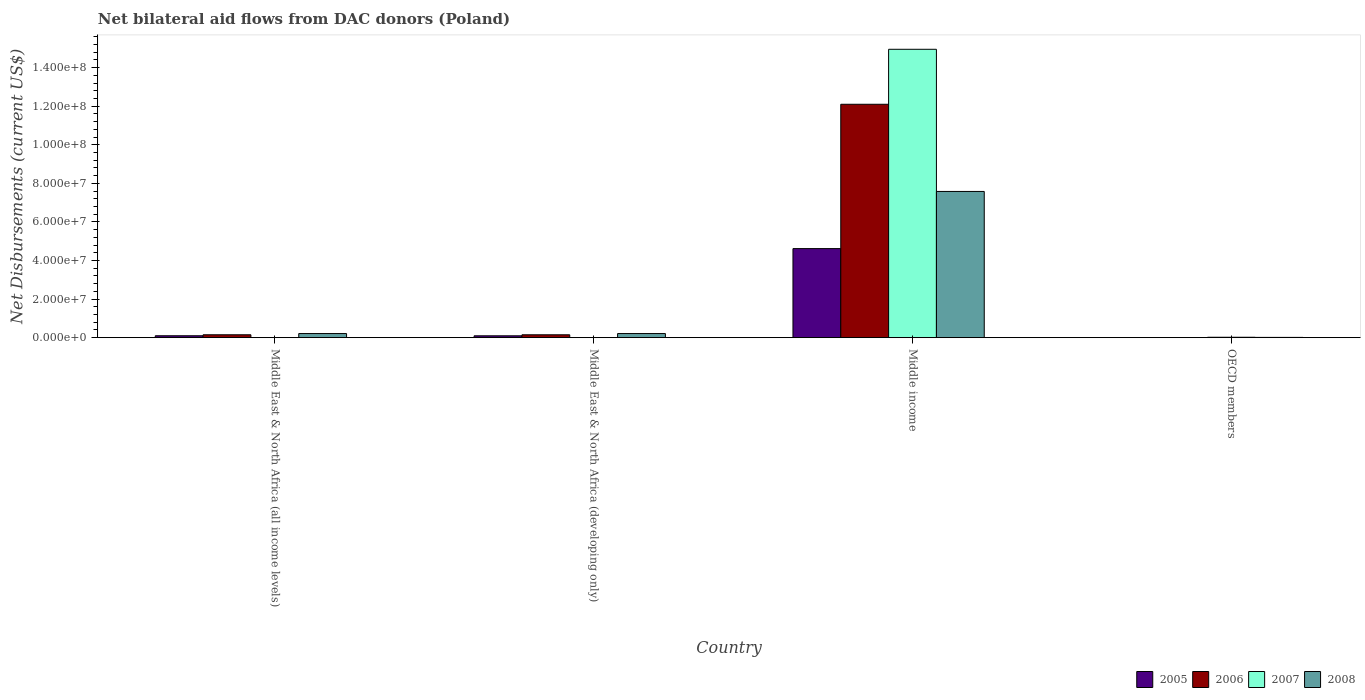Are the number of bars per tick equal to the number of legend labels?
Your response must be concise. No. Are the number of bars on each tick of the X-axis equal?
Keep it short and to the point. No. How many bars are there on the 1st tick from the left?
Keep it short and to the point. 3. How many bars are there on the 4th tick from the right?
Your answer should be compact. 3. What is the label of the 4th group of bars from the left?
Offer a very short reply. OECD members. What is the net bilateral aid flows in 2006 in Middle East & North Africa (developing only)?
Offer a very short reply. 1.49e+06. Across all countries, what is the maximum net bilateral aid flows in 2008?
Provide a short and direct response. 7.58e+07. Across all countries, what is the minimum net bilateral aid flows in 2006?
Your response must be concise. 3.00e+04. What is the total net bilateral aid flows in 2008 in the graph?
Keep it short and to the point. 8.02e+07. What is the difference between the net bilateral aid flows in 2006 in Middle East & North Africa (all income levels) and that in Middle income?
Keep it short and to the point. -1.20e+08. What is the difference between the net bilateral aid flows in 2008 in Middle East & North Africa (developing only) and the net bilateral aid flows in 2006 in OECD members?
Your answer should be very brief. 2.10e+06. What is the average net bilateral aid flows in 2006 per country?
Offer a terse response. 3.10e+07. In how many countries, is the net bilateral aid flows in 2008 greater than 56000000 US$?
Provide a short and direct response. 1. What is the ratio of the net bilateral aid flows in 2008 in Middle East & North Africa (all income levels) to that in Middle East & North Africa (developing only)?
Keep it short and to the point. 1. Is the net bilateral aid flows in 2008 in Middle East & North Africa (all income levels) less than that in Middle East & North Africa (developing only)?
Ensure brevity in your answer.  No. Is the difference between the net bilateral aid flows in 2005 in Middle East & North Africa (developing only) and OECD members greater than the difference between the net bilateral aid flows in 2008 in Middle East & North Africa (developing only) and OECD members?
Your response must be concise. No. What is the difference between the highest and the second highest net bilateral aid flows in 2005?
Offer a terse response. 4.52e+07. What is the difference between the highest and the lowest net bilateral aid flows in 2008?
Offer a terse response. 7.57e+07. In how many countries, is the net bilateral aid flows in 2007 greater than the average net bilateral aid flows in 2007 taken over all countries?
Make the answer very short. 1. How many bars are there?
Ensure brevity in your answer.  14. How many countries are there in the graph?
Provide a succinct answer. 4. Where does the legend appear in the graph?
Provide a short and direct response. Bottom right. How many legend labels are there?
Provide a succinct answer. 4. What is the title of the graph?
Your answer should be very brief. Net bilateral aid flows from DAC donors (Poland). What is the label or title of the X-axis?
Make the answer very short. Country. What is the label or title of the Y-axis?
Make the answer very short. Net Disbursements (current US$). What is the Net Disbursements (current US$) of 2005 in Middle East & North Africa (all income levels)?
Make the answer very short. 9.90e+05. What is the Net Disbursements (current US$) of 2006 in Middle East & North Africa (all income levels)?
Your response must be concise. 1.50e+06. What is the Net Disbursements (current US$) of 2007 in Middle East & North Africa (all income levels)?
Offer a terse response. 0. What is the Net Disbursements (current US$) of 2008 in Middle East & North Africa (all income levels)?
Offer a terse response. 2.13e+06. What is the Net Disbursements (current US$) of 2005 in Middle East & North Africa (developing only)?
Provide a short and direct response. 9.60e+05. What is the Net Disbursements (current US$) of 2006 in Middle East & North Africa (developing only)?
Provide a succinct answer. 1.49e+06. What is the Net Disbursements (current US$) in 2007 in Middle East & North Africa (developing only)?
Provide a succinct answer. 0. What is the Net Disbursements (current US$) in 2008 in Middle East & North Africa (developing only)?
Provide a succinct answer. 2.13e+06. What is the Net Disbursements (current US$) in 2005 in Middle income?
Make the answer very short. 4.62e+07. What is the Net Disbursements (current US$) in 2006 in Middle income?
Provide a short and direct response. 1.21e+08. What is the Net Disbursements (current US$) of 2007 in Middle income?
Give a very brief answer. 1.50e+08. What is the Net Disbursements (current US$) in 2008 in Middle income?
Ensure brevity in your answer.  7.58e+07. What is the Net Disbursements (current US$) of 2005 in OECD members?
Your answer should be very brief. 5.00e+04. What is the Net Disbursements (current US$) in 2006 in OECD members?
Offer a terse response. 3.00e+04. Across all countries, what is the maximum Net Disbursements (current US$) of 2005?
Offer a terse response. 4.62e+07. Across all countries, what is the maximum Net Disbursements (current US$) of 2006?
Make the answer very short. 1.21e+08. Across all countries, what is the maximum Net Disbursements (current US$) in 2007?
Your answer should be compact. 1.50e+08. Across all countries, what is the maximum Net Disbursements (current US$) of 2008?
Provide a succinct answer. 7.58e+07. Across all countries, what is the minimum Net Disbursements (current US$) in 2005?
Your response must be concise. 5.00e+04. Across all countries, what is the minimum Net Disbursements (current US$) in 2008?
Ensure brevity in your answer.  1.40e+05. What is the total Net Disbursements (current US$) in 2005 in the graph?
Give a very brief answer. 4.82e+07. What is the total Net Disbursements (current US$) in 2006 in the graph?
Make the answer very short. 1.24e+08. What is the total Net Disbursements (current US$) in 2007 in the graph?
Provide a succinct answer. 1.50e+08. What is the total Net Disbursements (current US$) of 2008 in the graph?
Offer a terse response. 8.02e+07. What is the difference between the Net Disbursements (current US$) of 2005 in Middle East & North Africa (all income levels) and that in Middle East & North Africa (developing only)?
Your answer should be very brief. 3.00e+04. What is the difference between the Net Disbursements (current US$) of 2008 in Middle East & North Africa (all income levels) and that in Middle East & North Africa (developing only)?
Your response must be concise. 0. What is the difference between the Net Disbursements (current US$) in 2005 in Middle East & North Africa (all income levels) and that in Middle income?
Your response must be concise. -4.52e+07. What is the difference between the Net Disbursements (current US$) of 2006 in Middle East & North Africa (all income levels) and that in Middle income?
Offer a terse response. -1.20e+08. What is the difference between the Net Disbursements (current US$) in 2008 in Middle East & North Africa (all income levels) and that in Middle income?
Ensure brevity in your answer.  -7.37e+07. What is the difference between the Net Disbursements (current US$) in 2005 in Middle East & North Africa (all income levels) and that in OECD members?
Ensure brevity in your answer.  9.40e+05. What is the difference between the Net Disbursements (current US$) in 2006 in Middle East & North Africa (all income levels) and that in OECD members?
Keep it short and to the point. 1.47e+06. What is the difference between the Net Disbursements (current US$) of 2008 in Middle East & North Africa (all income levels) and that in OECD members?
Keep it short and to the point. 1.99e+06. What is the difference between the Net Disbursements (current US$) of 2005 in Middle East & North Africa (developing only) and that in Middle income?
Make the answer very short. -4.52e+07. What is the difference between the Net Disbursements (current US$) in 2006 in Middle East & North Africa (developing only) and that in Middle income?
Offer a terse response. -1.20e+08. What is the difference between the Net Disbursements (current US$) in 2008 in Middle East & North Africa (developing only) and that in Middle income?
Ensure brevity in your answer.  -7.37e+07. What is the difference between the Net Disbursements (current US$) of 2005 in Middle East & North Africa (developing only) and that in OECD members?
Your response must be concise. 9.10e+05. What is the difference between the Net Disbursements (current US$) in 2006 in Middle East & North Africa (developing only) and that in OECD members?
Your response must be concise. 1.46e+06. What is the difference between the Net Disbursements (current US$) of 2008 in Middle East & North Africa (developing only) and that in OECD members?
Keep it short and to the point. 1.99e+06. What is the difference between the Net Disbursements (current US$) of 2005 in Middle income and that in OECD members?
Your answer should be very brief. 4.61e+07. What is the difference between the Net Disbursements (current US$) in 2006 in Middle income and that in OECD members?
Ensure brevity in your answer.  1.21e+08. What is the difference between the Net Disbursements (current US$) of 2007 in Middle income and that in OECD members?
Provide a succinct answer. 1.49e+08. What is the difference between the Net Disbursements (current US$) of 2008 in Middle income and that in OECD members?
Provide a succinct answer. 7.57e+07. What is the difference between the Net Disbursements (current US$) of 2005 in Middle East & North Africa (all income levels) and the Net Disbursements (current US$) of 2006 in Middle East & North Africa (developing only)?
Keep it short and to the point. -5.00e+05. What is the difference between the Net Disbursements (current US$) in 2005 in Middle East & North Africa (all income levels) and the Net Disbursements (current US$) in 2008 in Middle East & North Africa (developing only)?
Offer a very short reply. -1.14e+06. What is the difference between the Net Disbursements (current US$) of 2006 in Middle East & North Africa (all income levels) and the Net Disbursements (current US$) of 2008 in Middle East & North Africa (developing only)?
Make the answer very short. -6.30e+05. What is the difference between the Net Disbursements (current US$) of 2005 in Middle East & North Africa (all income levels) and the Net Disbursements (current US$) of 2006 in Middle income?
Offer a very short reply. -1.20e+08. What is the difference between the Net Disbursements (current US$) in 2005 in Middle East & North Africa (all income levels) and the Net Disbursements (current US$) in 2007 in Middle income?
Ensure brevity in your answer.  -1.49e+08. What is the difference between the Net Disbursements (current US$) in 2005 in Middle East & North Africa (all income levels) and the Net Disbursements (current US$) in 2008 in Middle income?
Offer a terse response. -7.48e+07. What is the difference between the Net Disbursements (current US$) of 2006 in Middle East & North Africa (all income levels) and the Net Disbursements (current US$) of 2007 in Middle income?
Your answer should be compact. -1.48e+08. What is the difference between the Net Disbursements (current US$) in 2006 in Middle East & North Africa (all income levels) and the Net Disbursements (current US$) in 2008 in Middle income?
Ensure brevity in your answer.  -7.43e+07. What is the difference between the Net Disbursements (current US$) in 2005 in Middle East & North Africa (all income levels) and the Net Disbursements (current US$) in 2006 in OECD members?
Provide a succinct answer. 9.60e+05. What is the difference between the Net Disbursements (current US$) of 2005 in Middle East & North Africa (all income levels) and the Net Disbursements (current US$) of 2007 in OECD members?
Your answer should be very brief. 7.80e+05. What is the difference between the Net Disbursements (current US$) of 2005 in Middle East & North Africa (all income levels) and the Net Disbursements (current US$) of 2008 in OECD members?
Your answer should be compact. 8.50e+05. What is the difference between the Net Disbursements (current US$) of 2006 in Middle East & North Africa (all income levels) and the Net Disbursements (current US$) of 2007 in OECD members?
Your answer should be compact. 1.29e+06. What is the difference between the Net Disbursements (current US$) of 2006 in Middle East & North Africa (all income levels) and the Net Disbursements (current US$) of 2008 in OECD members?
Provide a succinct answer. 1.36e+06. What is the difference between the Net Disbursements (current US$) of 2005 in Middle East & North Africa (developing only) and the Net Disbursements (current US$) of 2006 in Middle income?
Keep it short and to the point. -1.20e+08. What is the difference between the Net Disbursements (current US$) in 2005 in Middle East & North Africa (developing only) and the Net Disbursements (current US$) in 2007 in Middle income?
Offer a terse response. -1.49e+08. What is the difference between the Net Disbursements (current US$) in 2005 in Middle East & North Africa (developing only) and the Net Disbursements (current US$) in 2008 in Middle income?
Your answer should be very brief. -7.49e+07. What is the difference between the Net Disbursements (current US$) of 2006 in Middle East & North Africa (developing only) and the Net Disbursements (current US$) of 2007 in Middle income?
Your answer should be compact. -1.48e+08. What is the difference between the Net Disbursements (current US$) in 2006 in Middle East & North Africa (developing only) and the Net Disbursements (current US$) in 2008 in Middle income?
Offer a terse response. -7.43e+07. What is the difference between the Net Disbursements (current US$) of 2005 in Middle East & North Africa (developing only) and the Net Disbursements (current US$) of 2006 in OECD members?
Provide a short and direct response. 9.30e+05. What is the difference between the Net Disbursements (current US$) in 2005 in Middle East & North Africa (developing only) and the Net Disbursements (current US$) in 2007 in OECD members?
Your answer should be very brief. 7.50e+05. What is the difference between the Net Disbursements (current US$) of 2005 in Middle East & North Africa (developing only) and the Net Disbursements (current US$) of 2008 in OECD members?
Make the answer very short. 8.20e+05. What is the difference between the Net Disbursements (current US$) in 2006 in Middle East & North Africa (developing only) and the Net Disbursements (current US$) in 2007 in OECD members?
Provide a succinct answer. 1.28e+06. What is the difference between the Net Disbursements (current US$) of 2006 in Middle East & North Africa (developing only) and the Net Disbursements (current US$) of 2008 in OECD members?
Your answer should be very brief. 1.35e+06. What is the difference between the Net Disbursements (current US$) in 2005 in Middle income and the Net Disbursements (current US$) in 2006 in OECD members?
Give a very brief answer. 4.62e+07. What is the difference between the Net Disbursements (current US$) in 2005 in Middle income and the Net Disbursements (current US$) in 2007 in OECD members?
Provide a short and direct response. 4.60e+07. What is the difference between the Net Disbursements (current US$) in 2005 in Middle income and the Net Disbursements (current US$) in 2008 in OECD members?
Ensure brevity in your answer.  4.60e+07. What is the difference between the Net Disbursements (current US$) of 2006 in Middle income and the Net Disbursements (current US$) of 2007 in OECD members?
Offer a terse response. 1.21e+08. What is the difference between the Net Disbursements (current US$) in 2006 in Middle income and the Net Disbursements (current US$) in 2008 in OECD members?
Your answer should be compact. 1.21e+08. What is the difference between the Net Disbursements (current US$) in 2007 in Middle income and the Net Disbursements (current US$) in 2008 in OECD members?
Offer a terse response. 1.49e+08. What is the average Net Disbursements (current US$) of 2005 per country?
Offer a terse response. 1.20e+07. What is the average Net Disbursements (current US$) of 2006 per country?
Keep it short and to the point. 3.10e+07. What is the average Net Disbursements (current US$) of 2007 per country?
Your response must be concise. 3.74e+07. What is the average Net Disbursements (current US$) in 2008 per country?
Give a very brief answer. 2.01e+07. What is the difference between the Net Disbursements (current US$) of 2005 and Net Disbursements (current US$) of 2006 in Middle East & North Africa (all income levels)?
Your answer should be very brief. -5.10e+05. What is the difference between the Net Disbursements (current US$) in 2005 and Net Disbursements (current US$) in 2008 in Middle East & North Africa (all income levels)?
Keep it short and to the point. -1.14e+06. What is the difference between the Net Disbursements (current US$) of 2006 and Net Disbursements (current US$) of 2008 in Middle East & North Africa (all income levels)?
Offer a terse response. -6.30e+05. What is the difference between the Net Disbursements (current US$) of 2005 and Net Disbursements (current US$) of 2006 in Middle East & North Africa (developing only)?
Ensure brevity in your answer.  -5.30e+05. What is the difference between the Net Disbursements (current US$) of 2005 and Net Disbursements (current US$) of 2008 in Middle East & North Africa (developing only)?
Make the answer very short. -1.17e+06. What is the difference between the Net Disbursements (current US$) in 2006 and Net Disbursements (current US$) in 2008 in Middle East & North Africa (developing only)?
Keep it short and to the point. -6.40e+05. What is the difference between the Net Disbursements (current US$) in 2005 and Net Disbursements (current US$) in 2006 in Middle income?
Provide a short and direct response. -7.48e+07. What is the difference between the Net Disbursements (current US$) in 2005 and Net Disbursements (current US$) in 2007 in Middle income?
Your answer should be compact. -1.03e+08. What is the difference between the Net Disbursements (current US$) in 2005 and Net Disbursements (current US$) in 2008 in Middle income?
Provide a short and direct response. -2.96e+07. What is the difference between the Net Disbursements (current US$) of 2006 and Net Disbursements (current US$) of 2007 in Middle income?
Offer a terse response. -2.85e+07. What is the difference between the Net Disbursements (current US$) of 2006 and Net Disbursements (current US$) of 2008 in Middle income?
Provide a short and direct response. 4.52e+07. What is the difference between the Net Disbursements (current US$) in 2007 and Net Disbursements (current US$) in 2008 in Middle income?
Keep it short and to the point. 7.37e+07. What is the difference between the Net Disbursements (current US$) of 2005 and Net Disbursements (current US$) of 2006 in OECD members?
Offer a terse response. 2.00e+04. What is the difference between the Net Disbursements (current US$) in 2005 and Net Disbursements (current US$) in 2008 in OECD members?
Offer a terse response. -9.00e+04. What is the difference between the Net Disbursements (current US$) in 2006 and Net Disbursements (current US$) in 2008 in OECD members?
Make the answer very short. -1.10e+05. What is the ratio of the Net Disbursements (current US$) in 2005 in Middle East & North Africa (all income levels) to that in Middle East & North Africa (developing only)?
Offer a very short reply. 1.03. What is the ratio of the Net Disbursements (current US$) of 2006 in Middle East & North Africa (all income levels) to that in Middle East & North Africa (developing only)?
Ensure brevity in your answer.  1.01. What is the ratio of the Net Disbursements (current US$) in 2005 in Middle East & North Africa (all income levels) to that in Middle income?
Make the answer very short. 0.02. What is the ratio of the Net Disbursements (current US$) of 2006 in Middle East & North Africa (all income levels) to that in Middle income?
Provide a succinct answer. 0.01. What is the ratio of the Net Disbursements (current US$) of 2008 in Middle East & North Africa (all income levels) to that in Middle income?
Your answer should be compact. 0.03. What is the ratio of the Net Disbursements (current US$) in 2005 in Middle East & North Africa (all income levels) to that in OECD members?
Your answer should be very brief. 19.8. What is the ratio of the Net Disbursements (current US$) in 2006 in Middle East & North Africa (all income levels) to that in OECD members?
Provide a succinct answer. 50. What is the ratio of the Net Disbursements (current US$) in 2008 in Middle East & North Africa (all income levels) to that in OECD members?
Make the answer very short. 15.21. What is the ratio of the Net Disbursements (current US$) of 2005 in Middle East & North Africa (developing only) to that in Middle income?
Your answer should be very brief. 0.02. What is the ratio of the Net Disbursements (current US$) of 2006 in Middle East & North Africa (developing only) to that in Middle income?
Keep it short and to the point. 0.01. What is the ratio of the Net Disbursements (current US$) in 2008 in Middle East & North Africa (developing only) to that in Middle income?
Your answer should be compact. 0.03. What is the ratio of the Net Disbursements (current US$) of 2006 in Middle East & North Africa (developing only) to that in OECD members?
Your answer should be compact. 49.67. What is the ratio of the Net Disbursements (current US$) of 2008 in Middle East & North Africa (developing only) to that in OECD members?
Make the answer very short. 15.21. What is the ratio of the Net Disbursements (current US$) of 2005 in Middle income to that in OECD members?
Your answer should be very brief. 923.8. What is the ratio of the Net Disbursements (current US$) of 2006 in Middle income to that in OECD members?
Ensure brevity in your answer.  4034.67. What is the ratio of the Net Disbursements (current US$) in 2007 in Middle income to that in OECD members?
Keep it short and to the point. 712.14. What is the ratio of the Net Disbursements (current US$) in 2008 in Middle income to that in OECD members?
Your response must be concise. 541.64. What is the difference between the highest and the second highest Net Disbursements (current US$) of 2005?
Your answer should be very brief. 4.52e+07. What is the difference between the highest and the second highest Net Disbursements (current US$) in 2006?
Your answer should be compact. 1.20e+08. What is the difference between the highest and the second highest Net Disbursements (current US$) of 2008?
Keep it short and to the point. 7.37e+07. What is the difference between the highest and the lowest Net Disbursements (current US$) of 2005?
Your answer should be very brief. 4.61e+07. What is the difference between the highest and the lowest Net Disbursements (current US$) in 2006?
Ensure brevity in your answer.  1.21e+08. What is the difference between the highest and the lowest Net Disbursements (current US$) in 2007?
Offer a terse response. 1.50e+08. What is the difference between the highest and the lowest Net Disbursements (current US$) of 2008?
Provide a short and direct response. 7.57e+07. 